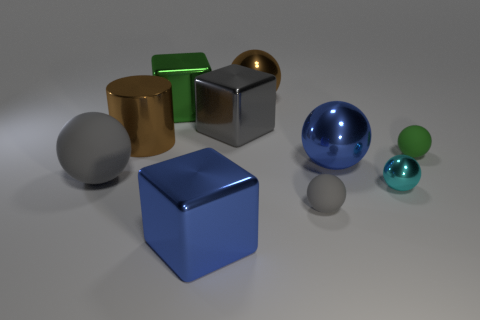Are there the same number of cyan spheres right of the brown shiny ball and green matte balls behind the big gray rubber sphere?
Provide a succinct answer. Yes. There is a gray matte object right of the big brown cylinder; are there any small green matte balls behind it?
Your response must be concise. Yes. The small cyan metal object has what shape?
Offer a terse response. Sphere. What size is the metal thing that is the same color as the metallic cylinder?
Offer a very short reply. Large. There is a cyan metallic sphere that is in front of the cylinder behind the small green matte sphere; what size is it?
Keep it short and to the point. Small. What is the size of the green thing that is in front of the large brown cylinder?
Keep it short and to the point. Small. Are there fewer tiny cyan metal things that are left of the small gray matte sphere than small green rubber things in front of the big matte thing?
Provide a succinct answer. No. What color is the large matte thing?
Offer a very short reply. Gray. Is there a big object of the same color as the cylinder?
Provide a short and direct response. Yes. The big metallic thing to the right of the brown thing that is to the right of the block in front of the gray block is what shape?
Keep it short and to the point. Sphere. 